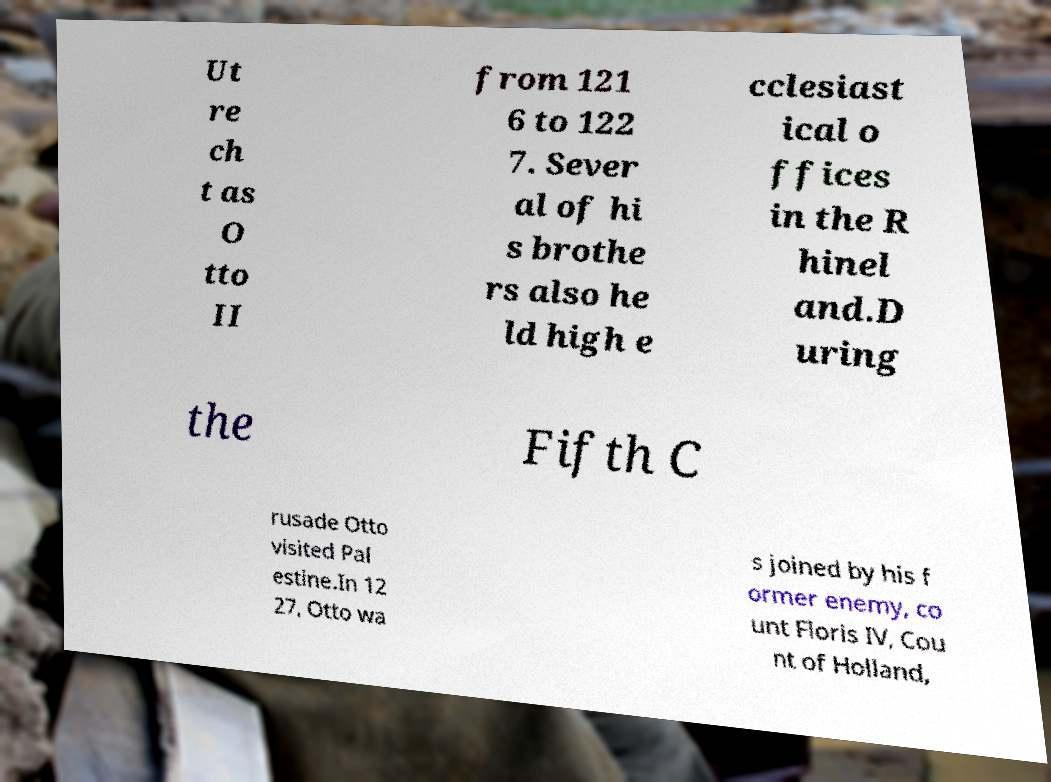Can you accurately transcribe the text from the provided image for me? Ut re ch t as O tto II from 121 6 to 122 7. Sever al of hi s brothe rs also he ld high e cclesiast ical o ffices in the R hinel and.D uring the Fifth C rusade Otto visited Pal estine.In 12 27, Otto wa s joined by his f ormer enemy, co unt Floris IV, Cou nt of Holland, 